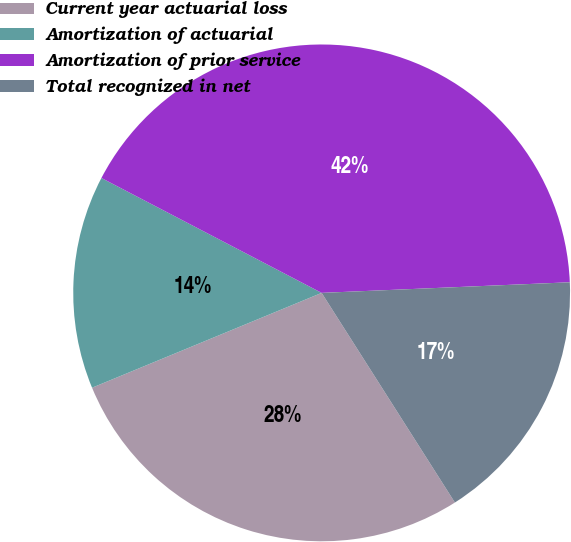Convert chart. <chart><loc_0><loc_0><loc_500><loc_500><pie_chart><fcel>Current year actuarial loss<fcel>Amortization of actuarial<fcel>Amortization of prior service<fcel>Total recognized in net<nl><fcel>27.78%<fcel>13.89%<fcel>41.67%<fcel>16.67%<nl></chart> 